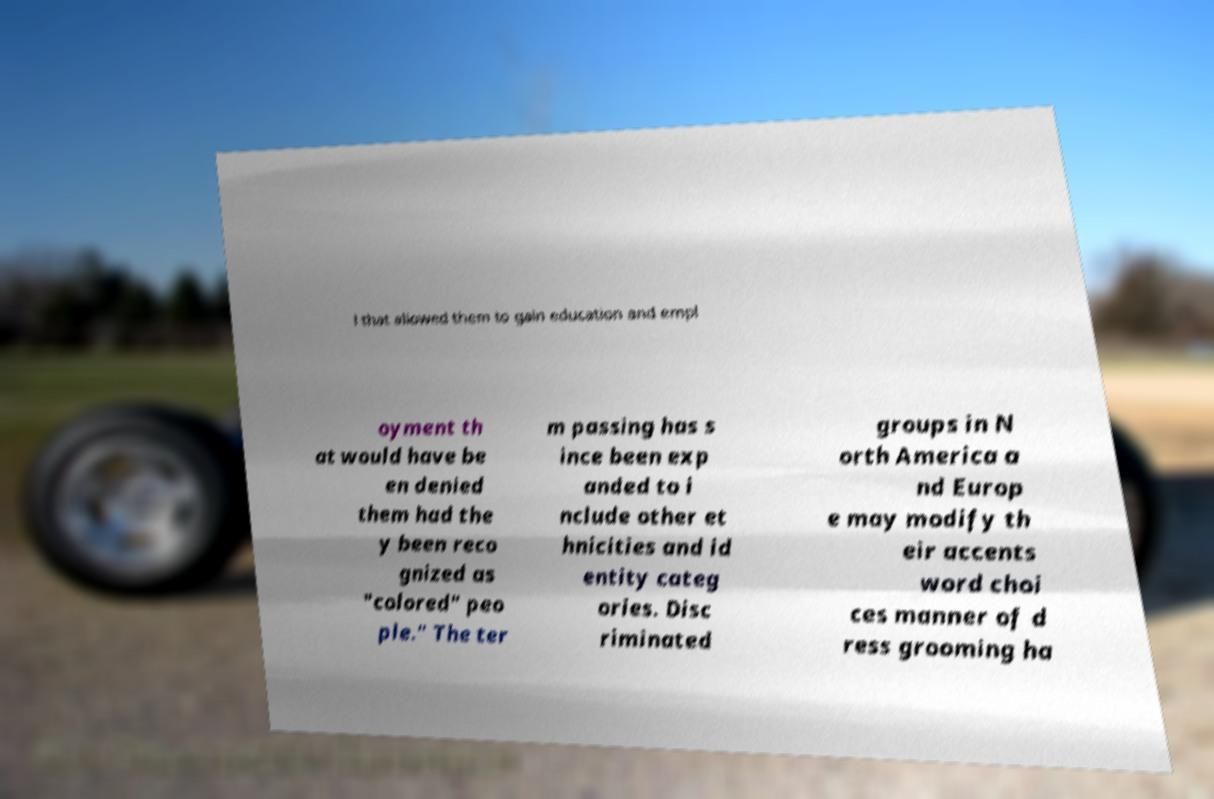What messages or text are displayed in this image? I need them in a readable, typed format. l that allowed them to gain education and empl oyment th at would have be en denied them had the y been reco gnized as "colored" peo ple." The ter m passing has s ince been exp anded to i nclude other et hnicities and id entity categ ories. Disc riminated groups in N orth America a nd Europ e may modify th eir accents word choi ces manner of d ress grooming ha 